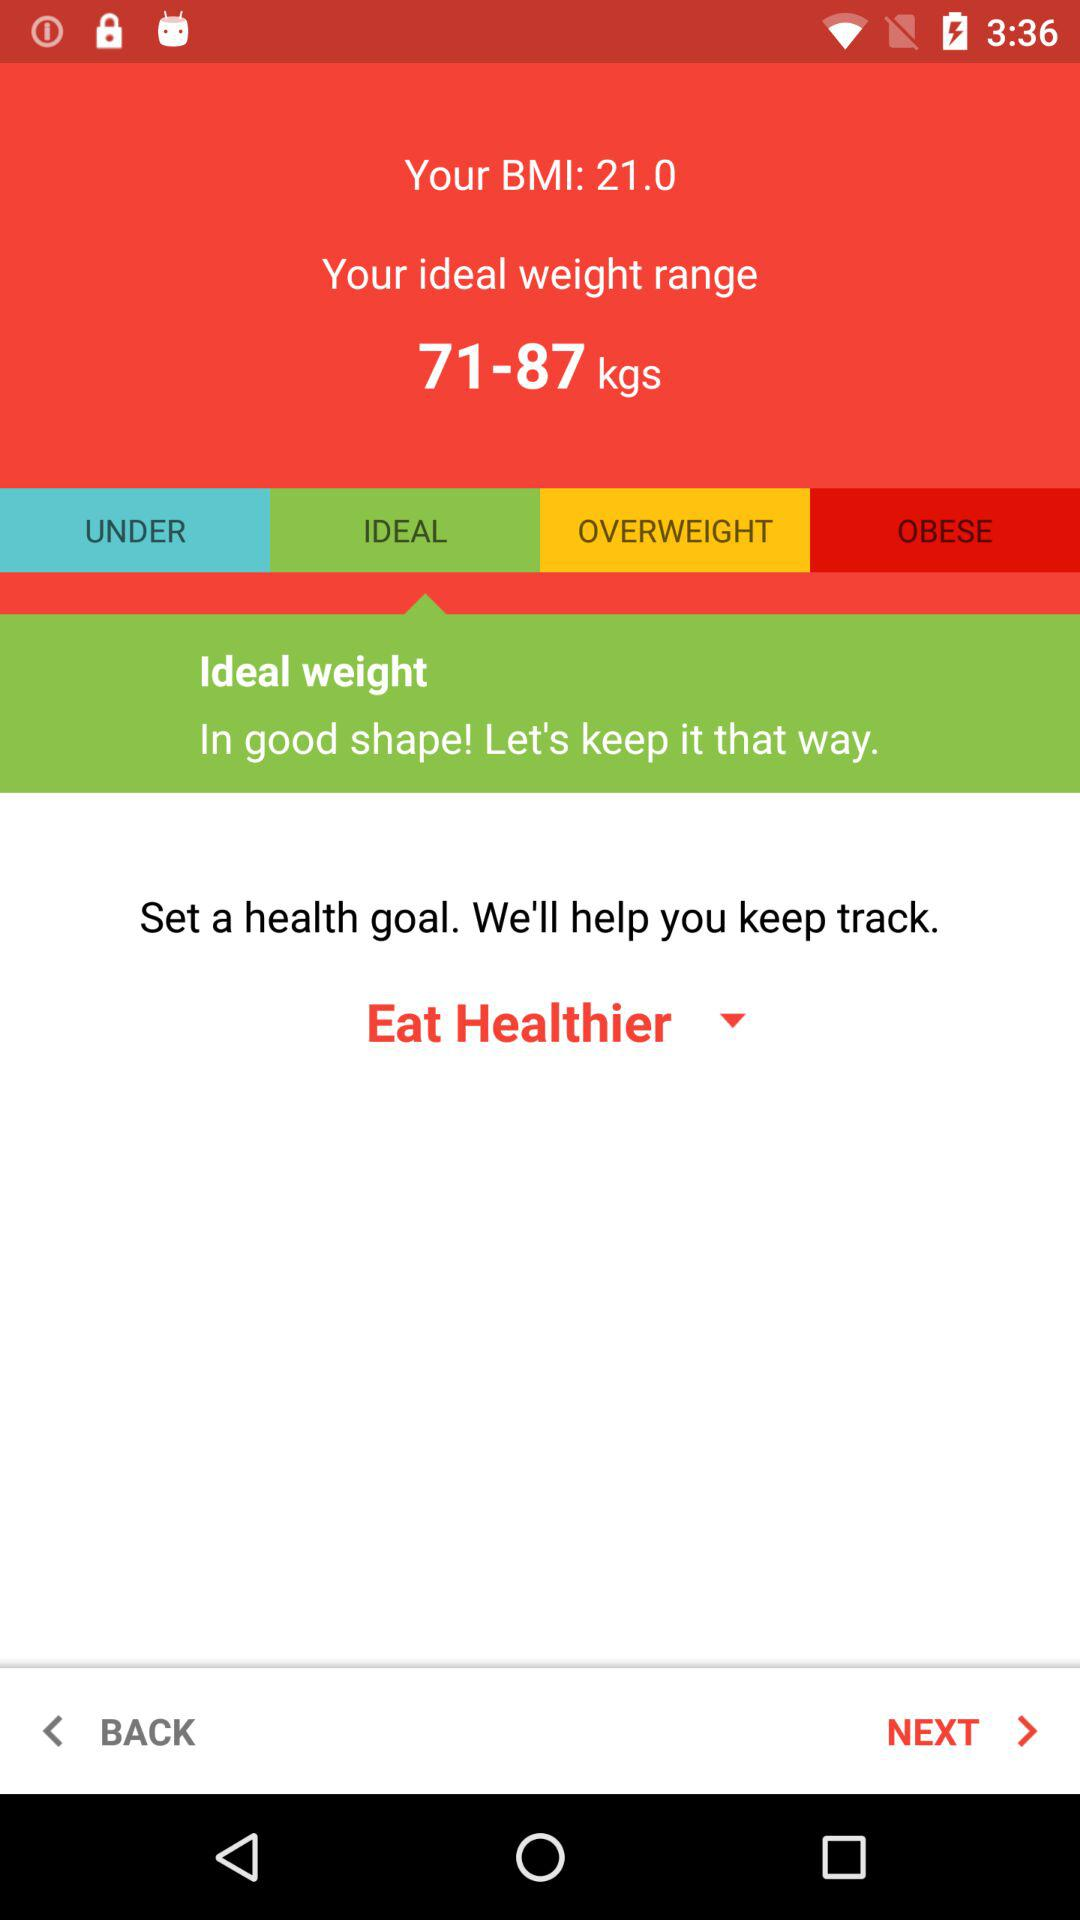What is the weight range? The weight range is from 71 to 87 kg. 